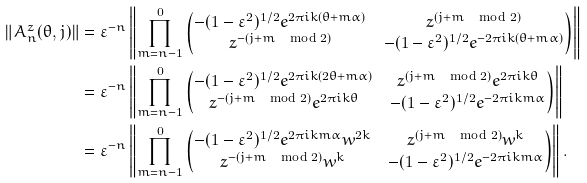<formula> <loc_0><loc_0><loc_500><loc_500>\| A ^ { z } _ { n } ( \theta , j ) \| & = \varepsilon ^ { - n } \left \| \prod _ { m = n - 1 } ^ { 0 } \begin{pmatrix} - ( 1 - \varepsilon ^ { 2 } ) ^ { 1 / 2 } e ^ { 2 \pi i k ( \theta + m \alpha ) } & z ^ { ( j + m \, \mod 2 ) } \\ z ^ { - ( j + m \, \mod 2 ) } & - ( 1 - \varepsilon ^ { 2 } ) ^ { 1 / 2 } e ^ { - 2 \pi i k ( \theta + m \alpha ) } \end{pmatrix} \right \| \\ & = \varepsilon ^ { - n } \left \| \prod _ { m = n - 1 } ^ { 0 } \begin{pmatrix} - ( 1 - \varepsilon ^ { 2 } ) ^ { 1 / 2 } e ^ { 2 \pi i k ( 2 \theta + m \alpha ) } & z ^ { ( j + m \, \mod 2 ) } e ^ { 2 \pi i k \theta } \\ z ^ { - ( j + m \, \mod 2 ) } e ^ { 2 \pi i k \theta } & - ( 1 - \varepsilon ^ { 2 } ) ^ { 1 / 2 } e ^ { - 2 \pi i k m \alpha } \end{pmatrix} \right \| \\ & = \varepsilon ^ { - n } \left \| \prod _ { m = n - 1 } ^ { 0 } \begin{pmatrix} - ( 1 - \varepsilon ^ { 2 } ) ^ { 1 / 2 } e ^ { 2 \pi i k m \alpha } w ^ { 2 k } & z ^ { ( j + m \, \mod 2 ) } w ^ { k } \\ z ^ { - ( j + m \, \mod 2 ) } w ^ { k } & - ( 1 - \varepsilon ^ { 2 } ) ^ { 1 / 2 } e ^ { - 2 \pi i k m \alpha } \end{pmatrix} \right \| .</formula> 